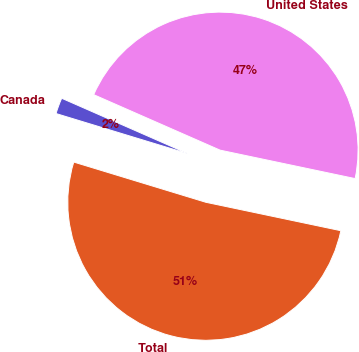<chart> <loc_0><loc_0><loc_500><loc_500><pie_chart><fcel>United States<fcel>Canada<fcel>Total<nl><fcel>46.72%<fcel>1.88%<fcel>51.4%<nl></chart> 